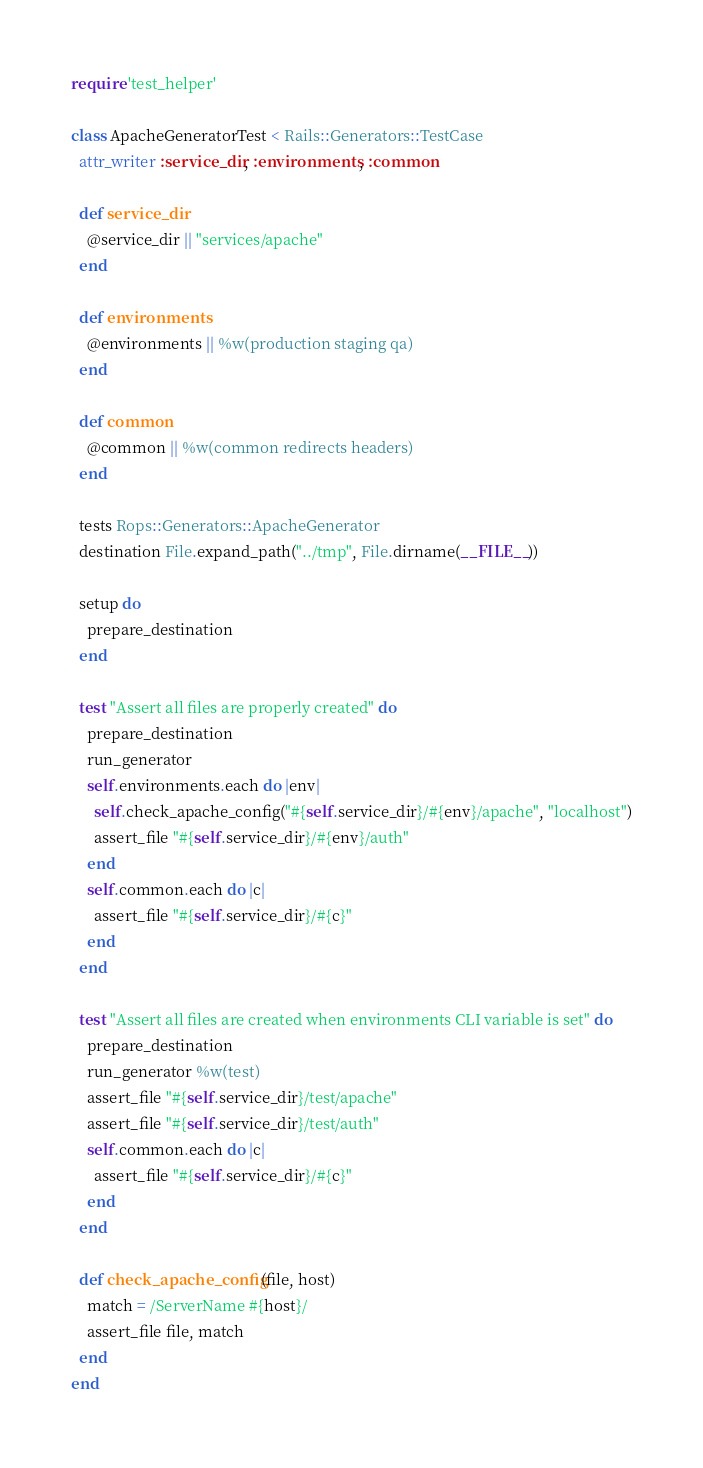Convert code to text. <code><loc_0><loc_0><loc_500><loc_500><_Ruby_>require 'test_helper'

class ApacheGeneratorTest < Rails::Generators::TestCase
  attr_writer :service_dir, :environments, :common

  def service_dir
    @service_dir || "services/apache"
  end

  def environments
    @environments || %w(production staging qa)
  end

  def common
    @common || %w(common redirects headers)
  end

  tests Rops::Generators::ApacheGenerator
  destination File.expand_path("../tmp", File.dirname(__FILE__))

  setup do
    prepare_destination
  end

  test "Assert all files are properly created" do
    prepare_destination
    run_generator
    self.environments.each do |env|
      self.check_apache_config("#{self.service_dir}/#{env}/apache", "localhost")
      assert_file "#{self.service_dir}/#{env}/auth"
    end
    self.common.each do |c|
      assert_file "#{self.service_dir}/#{c}"
    end
  end

  test "Assert all files are created when environments CLI variable is set" do
    prepare_destination
    run_generator %w(test)
    assert_file "#{self.service_dir}/test/apache"
    assert_file "#{self.service_dir}/test/auth"
    self.common.each do |c|
      assert_file "#{self.service_dir}/#{c}"
    end
  end

  def check_apache_config(file, host)
    match = /ServerName #{host}/
    assert_file file, match
  end
end
</code> 